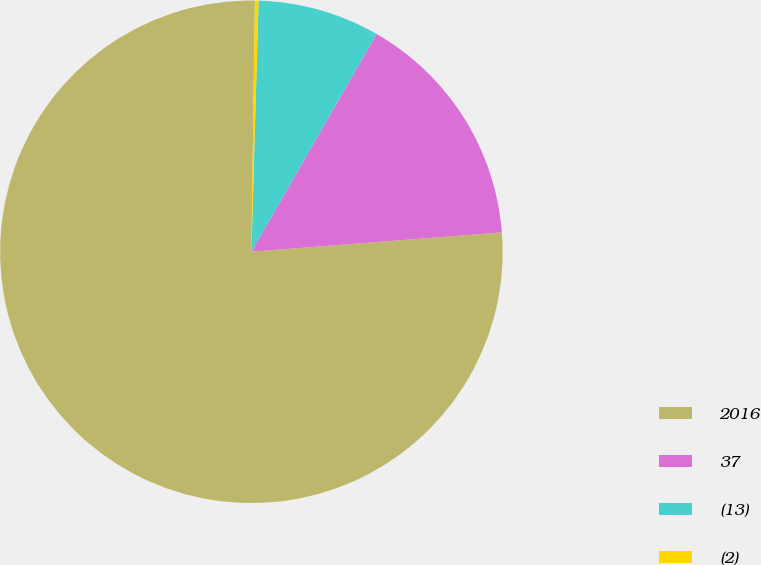Convert chart to OTSL. <chart><loc_0><loc_0><loc_500><loc_500><pie_chart><fcel>2016<fcel>37<fcel>(13)<fcel>(2)<nl><fcel>76.45%<fcel>15.47%<fcel>7.85%<fcel>0.23%<nl></chart> 